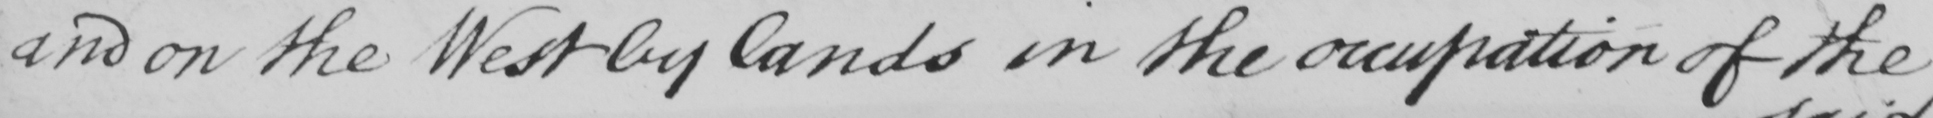Can you tell me what this handwritten text says? and on the West by lands in the occupation of the 